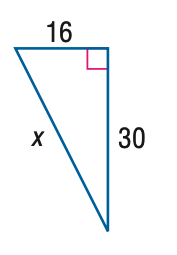Answer the mathemtical geometry problem and directly provide the correct option letter.
Question: Use a Pythagorean Triple to find x.
Choices: A: 32 B: 34 C: 36 D: 38 B 